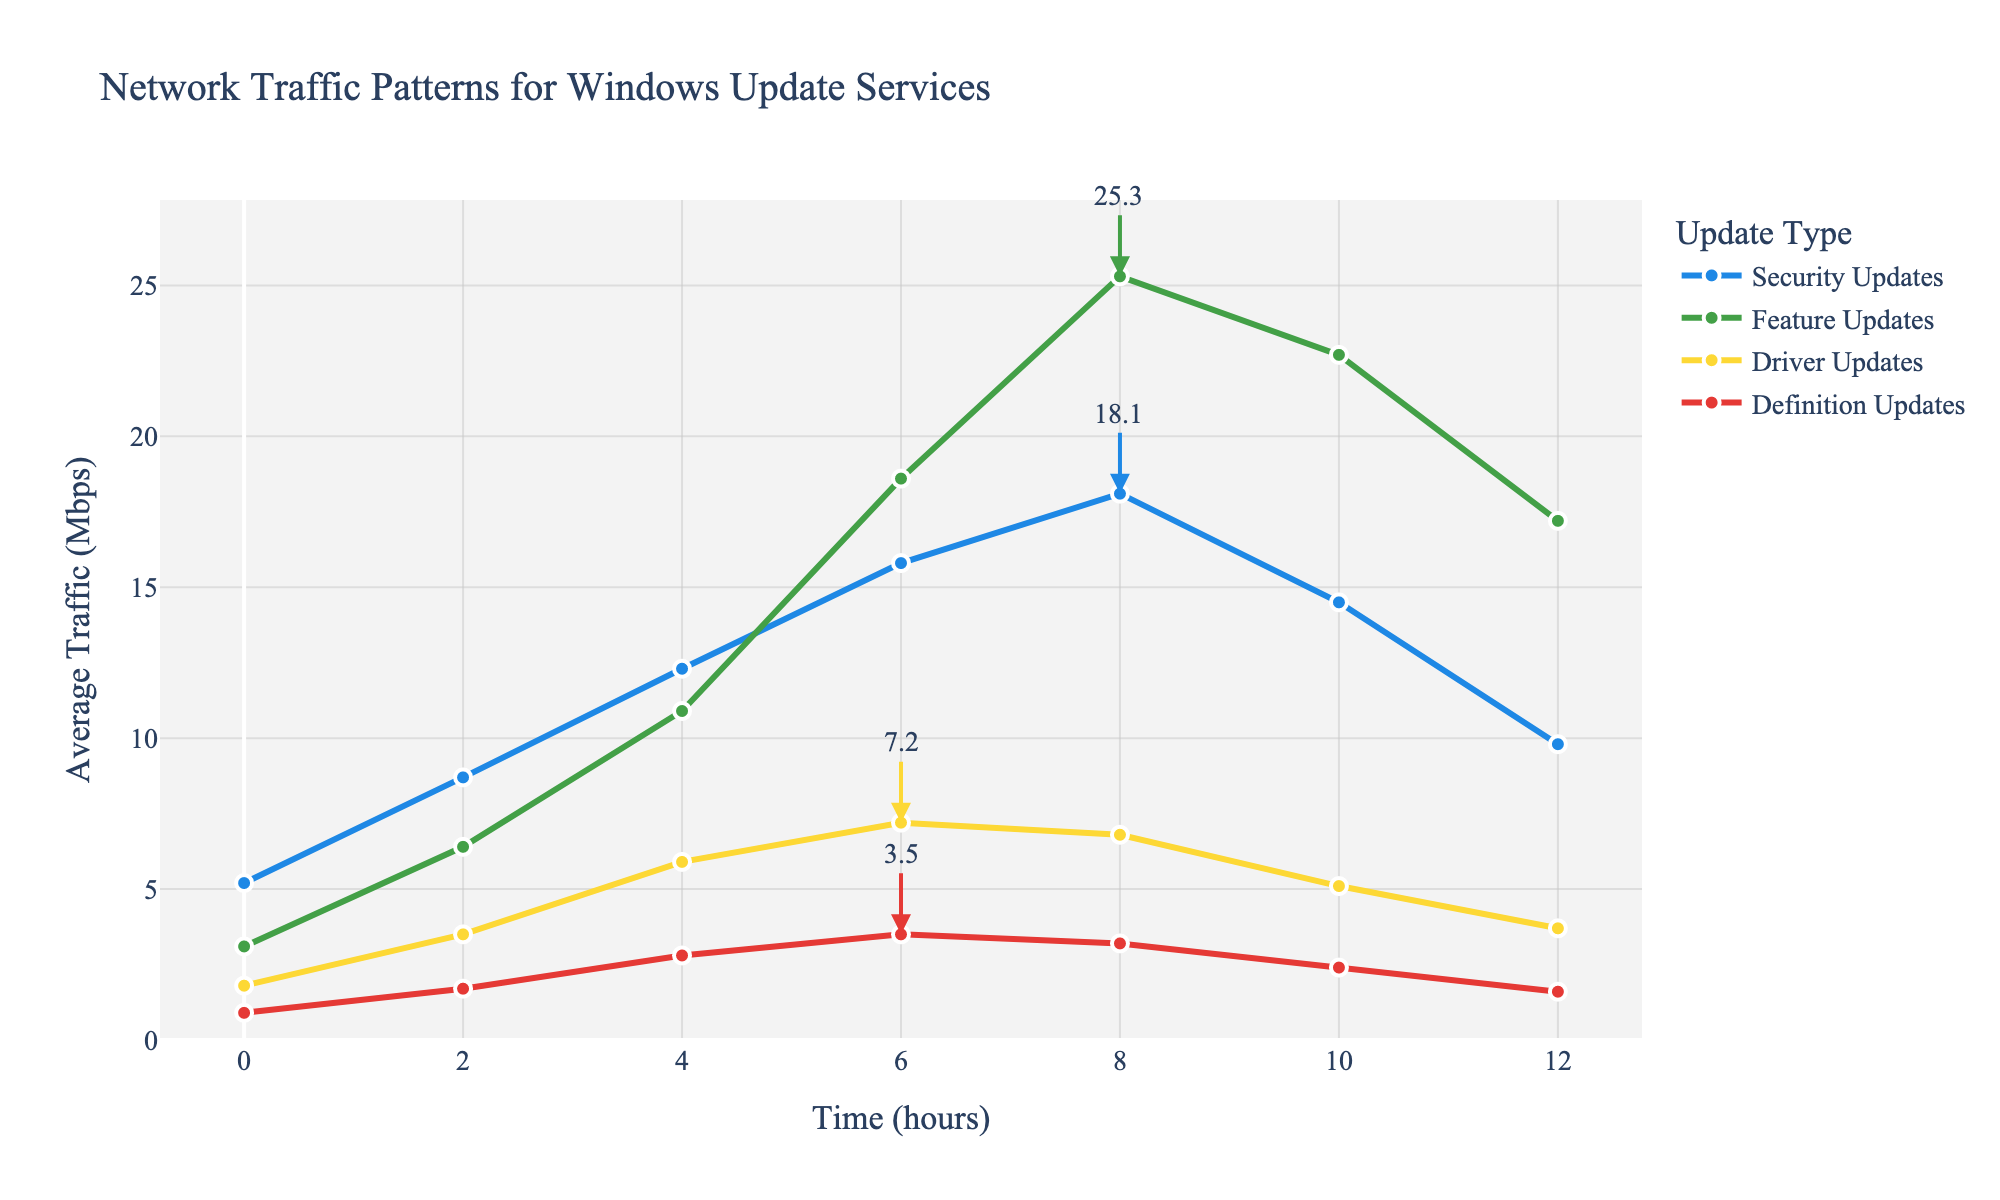What is the maximum average traffic for Security Updates and at what time does it occur? The chart shows the highest point for Security Updates and the annotation indicates this. The peak average traffic for Security Updates is 18.1 Mbps, occurring at 8 hours.
Answer: 18.1 Mbps at 8 hours Which update type has the highest overall peak average traffic, and what is the value? By comparing the highest points of all lines, we see Feature Updates reach the highest average traffic at 25.3 Mbps.
Answer: Feature Updates, 25.3 Mbps At what time do Feature Updates have their peak average traffic, and what is the value? Looking at the Feature Updates line, the peak is at 8 hours where the annotation shows 25.3 Mbps.
Answer: 8 hours, 25.3 Mbps Compare the average traffic of Driver Updates and Definition Updates at 6 hours. Which is higher and by how much? Driver Updates have an average traffic of 7.2 Mbps, and Definition Updates have 3.5 Mbps at 6 hours. Subtracting 3.5 from 7.2 gives 3.7 Mbps.
Answer: Driver Updates are higher by 3.7 Mbps Which update type has the lowest peak average traffic, and what is the value? The lowest peak is found by comparing the highest points of all lines. Definition Updates have the lowest peak at 3.5 Mbps.
Answer: Definition Updates, 3.5 Mbps What is the average traffic of Feature Updates at 10 hours? The chart shows the point for Feature Updates at 10 hours, which is 22.7 Mbps.
Answer: 22.7 Mbps How many update types have a peak average traffic above 15 Mbps? Reviewing the peak points, Security Updates (18.1 Mbps) and Feature Updates (25.3 Mbps) are above 15 Mbps. Two update types meet this criterion.
Answer: 2 What is the time interval (in hours) between the points where Security Updates reach 15.8 Mbps and drop to 14.5 Mbps? The chart shows Security Updates reach 15.8 Mbps at 6 hours and drops to 14.5 Mbps at 10 hours. The interval is 10 - 6 = 4 hours.
Answer: 4 hours Compare the average traffic of Security Updates and Feature Updates at 4 hours. Which is higher and by how much? Security Updates have an average traffic of 12.3 Mbps, and Feature Updates have 10.9 Mbps at 4 hours. The difference is 12.3 - 10.9 = 1.4 Mbps.
Answer: Security Updates are higher by 1.4 Mbps Between 2 and 4 hours, which update type shows the greatest increase in average traffic? Calculating the increase from 2 to 4 hours, Security Updates increase by 12.3 - 8.7 = 3.6 Mbps, Feature Updates by 10.9 - 6.4 = 4.5 Mbps, Driver Updates by 5.9 - 3.5 = 2.4 Mbps, and Definition Updates by 2.8 - 1.7 = 1.1 Mbps. Feature Updates have the greatest increase of 4.5 Mbps.
Answer: Feature Updates, 4.5 Mbps 